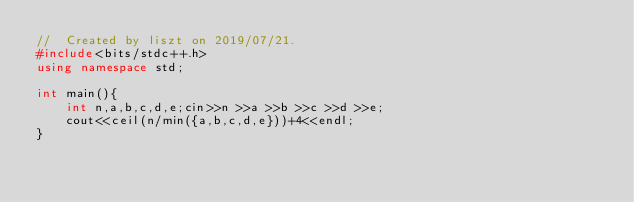Convert code to text. <code><loc_0><loc_0><loc_500><loc_500><_C++_>//  Created by liszt on 2019/07/21.
#include<bits/stdc++.h>
using namespace std;

int main(){
    int n,a,b,c,d,e;cin>>n >>a >>b >>c >>d >>e;
    cout<<ceil(n/min({a,b,c,d,e}))+4<<endl;
}</code> 